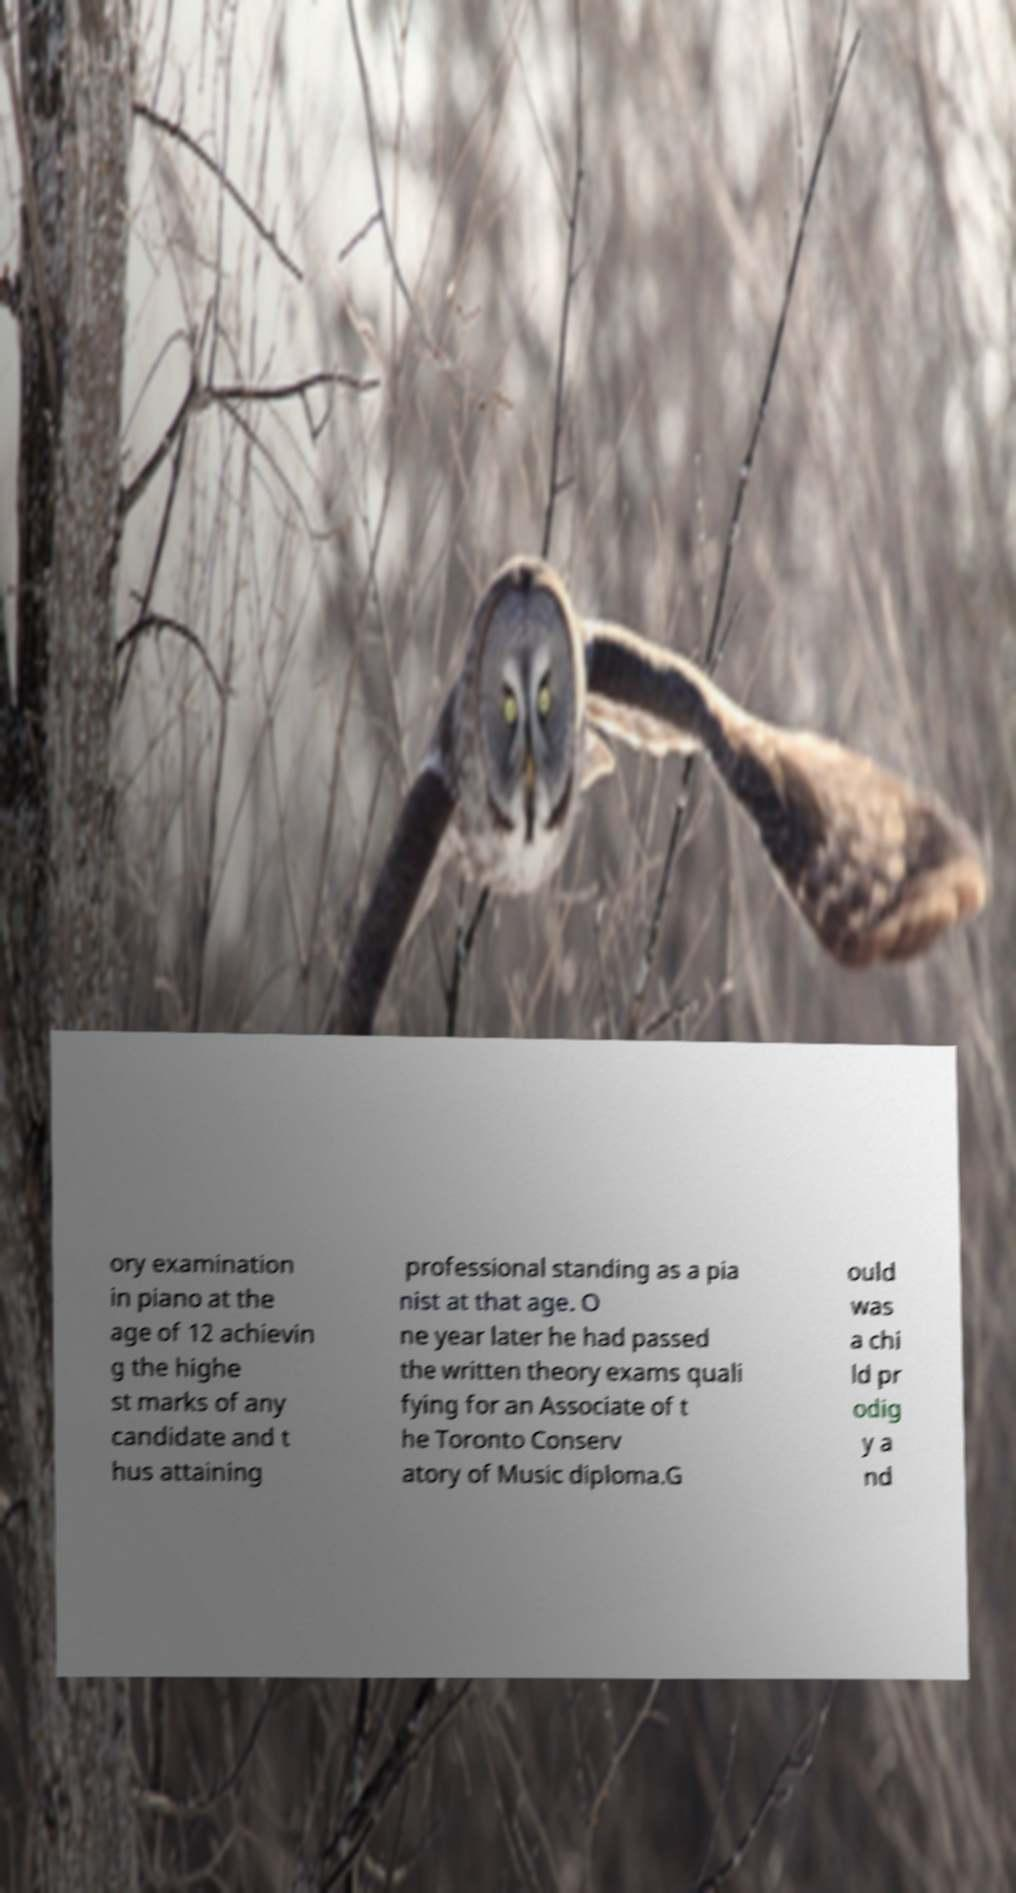What messages or text are displayed in this image? I need them in a readable, typed format. ory examination in piano at the age of 12 achievin g the highe st marks of any candidate and t hus attaining professional standing as a pia nist at that age. O ne year later he had passed the written theory exams quali fying for an Associate of t he Toronto Conserv atory of Music diploma.G ould was a chi ld pr odig y a nd 